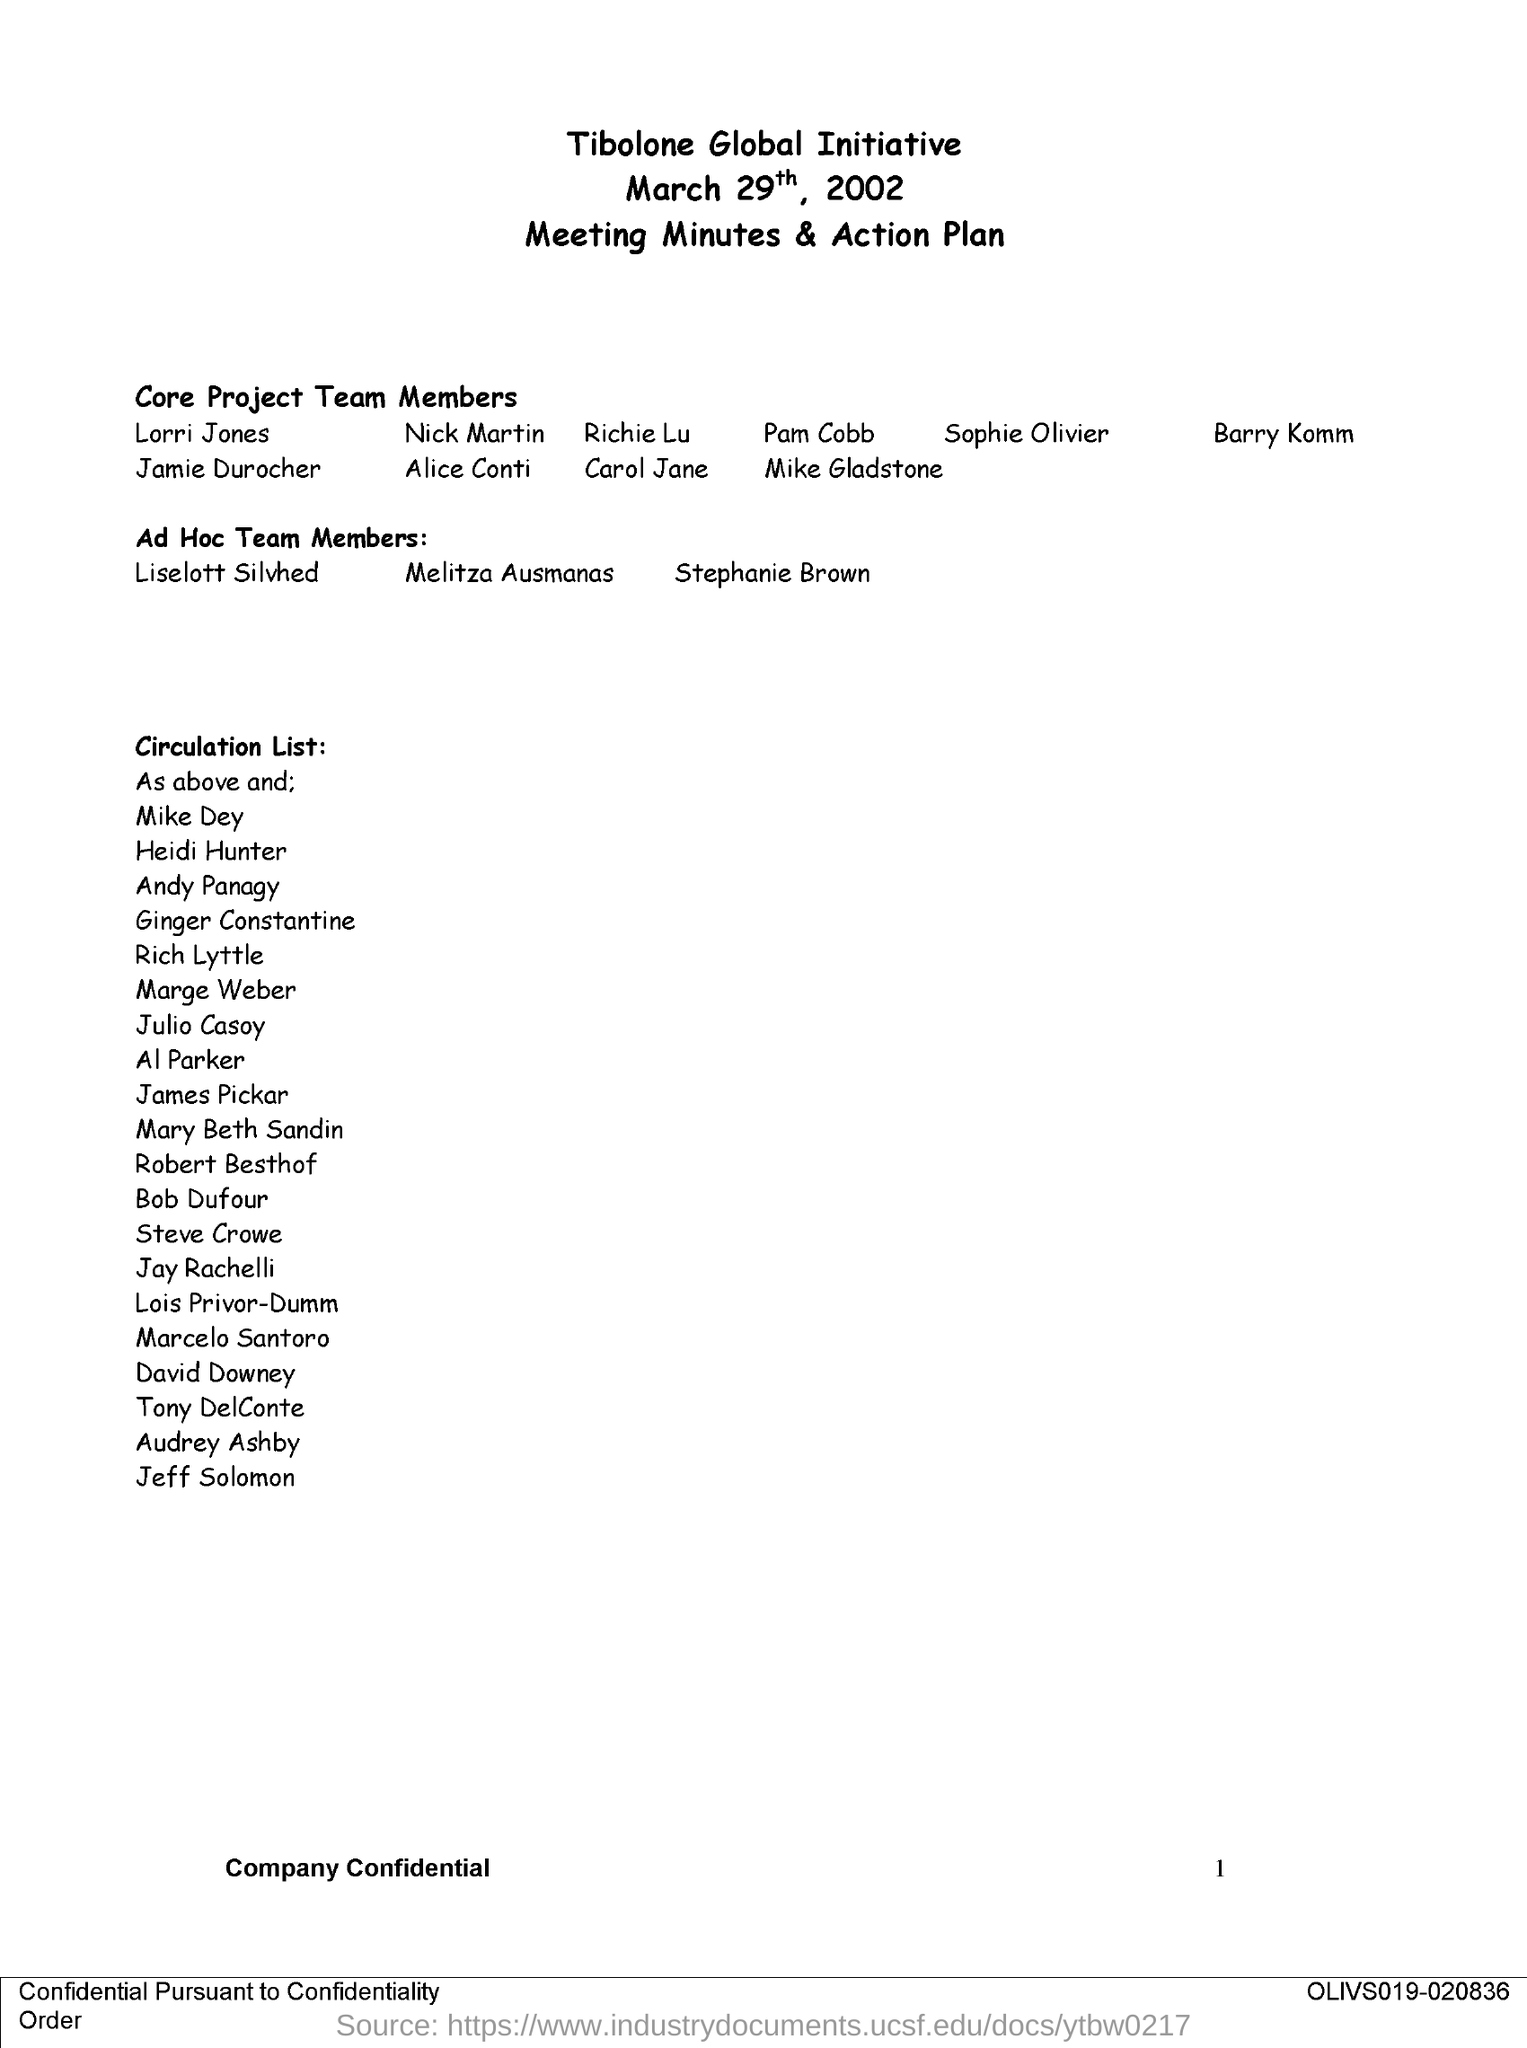What is the date on the document?
Provide a short and direct response. March 29th, 2002. 